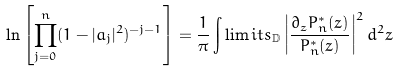Convert formula to latex. <formula><loc_0><loc_0><loc_500><loc_500>\ln \left [ \prod _ { j = 0 } ^ { n } ( 1 - | a _ { j } | ^ { 2 } ) ^ { - j - 1 } \right ] = \frac { 1 } { \pi } \int \lim i t s _ { \mathbb { D } } \left | \frac { \partial _ { z } P _ { n } ^ { * } ( z ) } { P _ { n } ^ { * } ( z ) } \right | ^ { 2 } d ^ { 2 } z</formula> 